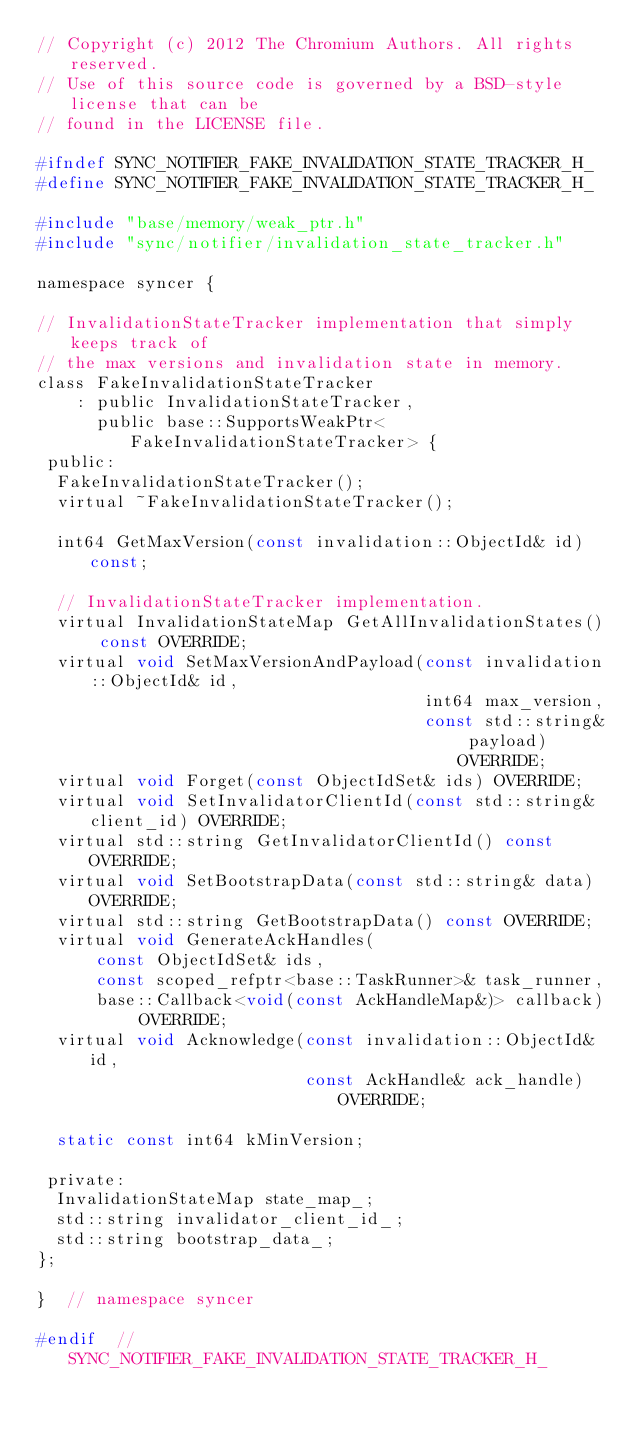Convert code to text. <code><loc_0><loc_0><loc_500><loc_500><_C_>// Copyright (c) 2012 The Chromium Authors. All rights reserved.
// Use of this source code is governed by a BSD-style license that can be
// found in the LICENSE file.

#ifndef SYNC_NOTIFIER_FAKE_INVALIDATION_STATE_TRACKER_H_
#define SYNC_NOTIFIER_FAKE_INVALIDATION_STATE_TRACKER_H_

#include "base/memory/weak_ptr.h"
#include "sync/notifier/invalidation_state_tracker.h"

namespace syncer {

// InvalidationStateTracker implementation that simply keeps track of
// the max versions and invalidation state in memory.
class FakeInvalidationStateTracker
    : public InvalidationStateTracker,
      public base::SupportsWeakPtr<FakeInvalidationStateTracker> {
 public:
  FakeInvalidationStateTracker();
  virtual ~FakeInvalidationStateTracker();

  int64 GetMaxVersion(const invalidation::ObjectId& id) const;

  // InvalidationStateTracker implementation.
  virtual InvalidationStateMap GetAllInvalidationStates() const OVERRIDE;
  virtual void SetMaxVersionAndPayload(const invalidation::ObjectId& id,
                                       int64 max_version,
                                       const std::string& payload) OVERRIDE;
  virtual void Forget(const ObjectIdSet& ids) OVERRIDE;
  virtual void SetInvalidatorClientId(const std::string& client_id) OVERRIDE;
  virtual std::string GetInvalidatorClientId() const OVERRIDE;
  virtual void SetBootstrapData(const std::string& data) OVERRIDE;
  virtual std::string GetBootstrapData() const OVERRIDE;
  virtual void GenerateAckHandles(
      const ObjectIdSet& ids,
      const scoped_refptr<base::TaskRunner>& task_runner,
      base::Callback<void(const AckHandleMap&)> callback) OVERRIDE;
  virtual void Acknowledge(const invalidation::ObjectId& id,
                           const AckHandle& ack_handle) OVERRIDE;

  static const int64 kMinVersion;

 private:
  InvalidationStateMap state_map_;
  std::string invalidator_client_id_;
  std::string bootstrap_data_;
};

}  // namespace syncer

#endif  // SYNC_NOTIFIER_FAKE_INVALIDATION_STATE_TRACKER_H_
</code> 